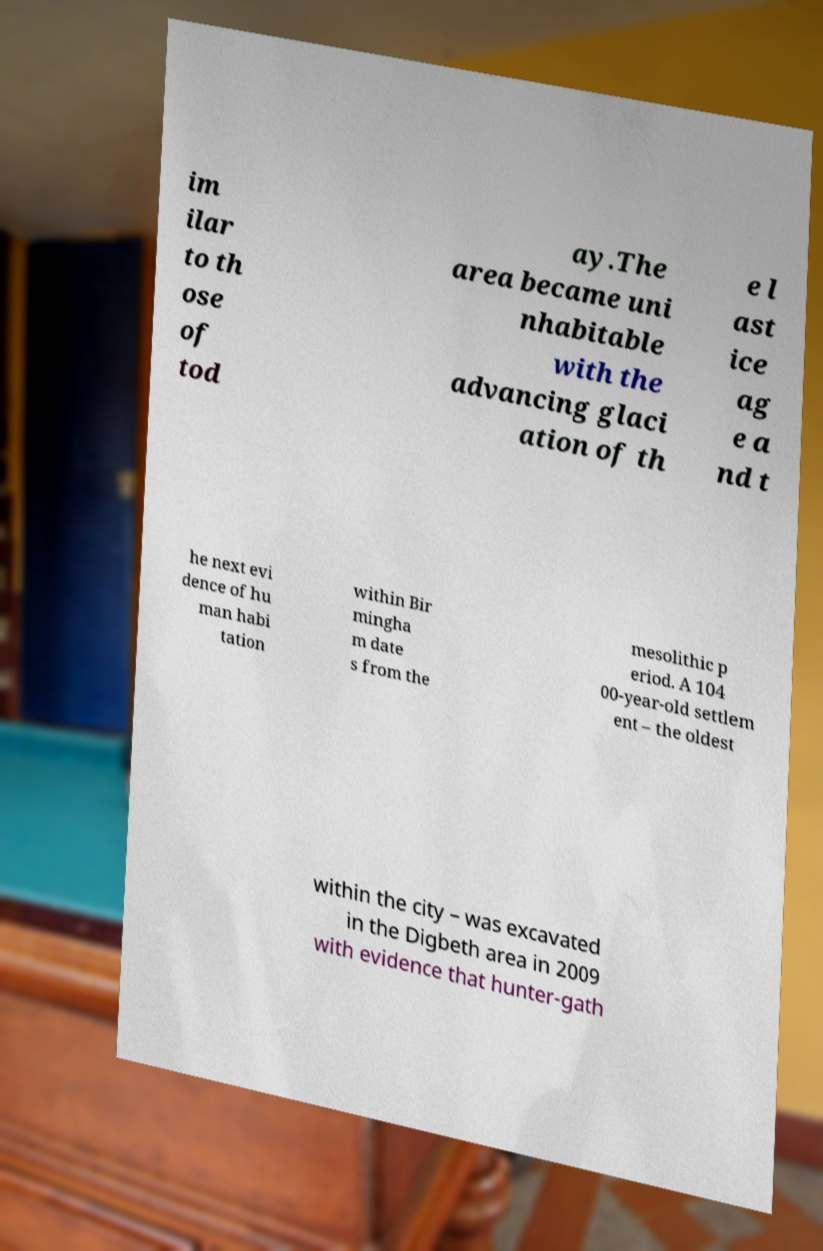What messages or text are displayed in this image? I need them in a readable, typed format. im ilar to th ose of tod ay.The area became uni nhabitable with the advancing glaci ation of th e l ast ice ag e a nd t he next evi dence of hu man habi tation within Bir mingha m date s from the mesolithic p eriod. A 104 00-year-old settlem ent – the oldest within the city – was excavated in the Digbeth area in 2009 with evidence that hunter-gath 